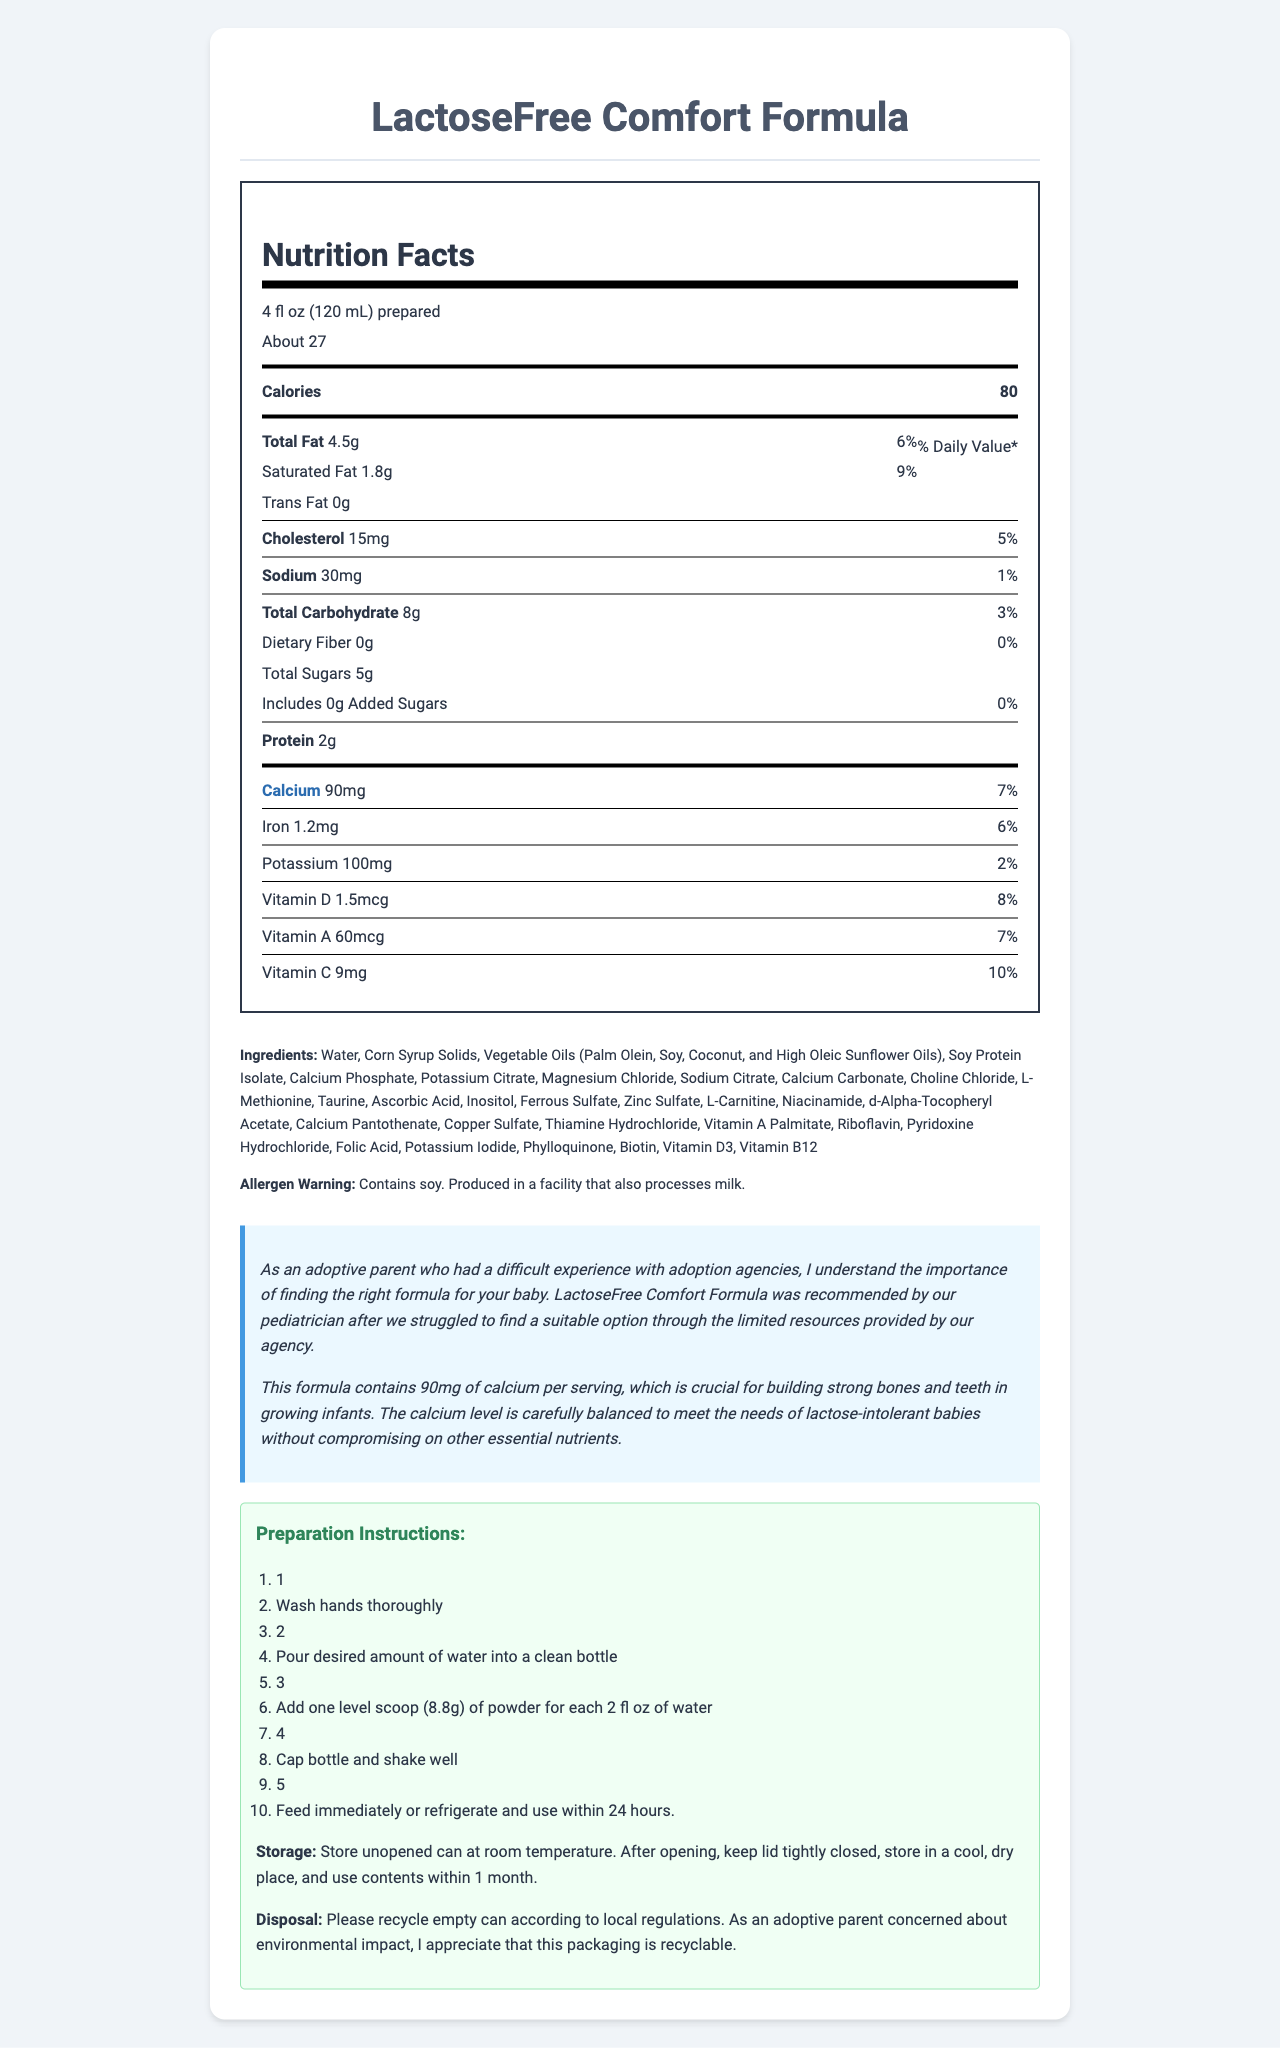what is the serving size? The serving size is mentioned specifically in the Nutrition Facts header at the top of the label.
Answer: 4 fl oz (120 mL) prepared how many servings are there per container? The label specifies that there are about 27 servings per container.
Answer: About 27 what percentage of the daily value of calcium does one serving provide? The daily value percentage for calcium is listed as 7% next to the amount of calcium.
Answer: 7% how much cholesterol is in one serving? The amount of cholesterol per serving is listed in the Nutrition Facts section as 15mg.
Answer: 15mg what ingredients are used in this formula? The ingredients are listed in a separate section beneath the nutrition facts.
Answer: Water, Corn Syrup Solids, Vegetable Oils (Palm Olein, Soy, Coconut, and High Oleic Sunflower Oils), Soy Protein Isolate, Calcium Phosphate, Potassium Citrate, Magnesium Chloride, Sodium Citrate, Calcium Carbonate, Choline Chloride, L-Methionine, Taurine, Ascorbic Acid, Inositol, Ferrous Sulfate, Zinc Sulfate, L-Carnitine, Niacinamide, d-Alpha-Tocopheryl Acetate, Calcium Pantothenate, Copper Sulfate, Thiamine Hydrochloride, Vitamin A Palmitate, Riboflavin, Pyridoxine Hydrochloride, Folic Acid, Potassium Iodide, Phylloquinone, Biotin, Vitamin D3, Vitamin B12 how many calories are in a serving? The calorie content per serving is mentioned at the top of the Nutrition Facts section as 80 calories.
Answer: 80 which nutrient has the highest daily value percentage in one serving?
A. Vitamin D
B. Iron
C. Vitamin C Vitamin D - 8%, Iron - 6%, Vitamin C - 10%. Vitamin C has the highest daily value percentage.
Answer: C what is the exact amount of calcium in one serving? The amount of calcium per serving is specified as 90mg in the Nutrition Facts section.
Answer: 90mg is the formula suitable for lactose-intolerant babies? The text emphasizes that the formula is designed for lactose-intolerant babies and meets their nutritional needs.
Answer: Yes which vitamin has the lowest daily value percentage in one serving?
A. Vitamin D
B. Vitamin A
C. Vitamin C Vitamin D - 8%, Vitamin A - 7%, Vitamin C - 10%. Vitamin A has the lowest daily value percentage.
Answer: B does the formula contain soy? The allergen warning section specifically mentions that the formula contains soy.
Answer: Yes how should the formula be stored after opening? The storage instructions detail how to store the formula after opening.
Answer: Store in a cool, dry place, keep the lid tightly closed, and use contents within 1 month how many grams of protein are in one serving? The protein content per serving is listed as 2g in the Nutrition Facts section.
Answer: 2g is it mentioned whether the packaging is recyclable? The disposal information section specifies that the packaging is recyclable and encourages recycling according to local regulations.
Answer: Yes does the formula contain added sugars? The Nutrition Facts section lists added sugars as 0g.
Answer: No summarize the entire document in a few sentences. The summary captures all main aspects of the document such as nutritional content, health benefits, preparation and storage instructions, and allergen warnings.
Answer: The document provides comprehensive nutritional information and details for the LactoseFree Comfort Formula, which is suitable for lactose-intolerant babies. It lists nutritional content per serving, including calories, fats, cholesterol, sodium, carbohydrates, proteins, vitamins, and minerals. The document emphasizes the importance of calcium for bone and teeth development in infants and includes preparation, storage, and disposal instructions along with allergen warnings. what is the source of the formula's protein? The ingredients list includes soy protein isolate, which likely contributes to the protein content, but this is not specifically stated in the document text.
Answer: Not explicitly stated 